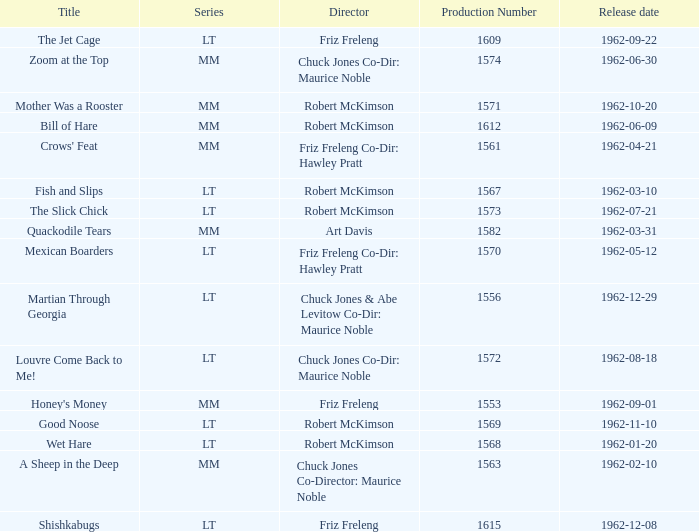What date was Wet Hare, directed by Robert McKimson, released? 1962-01-20. Could you parse the entire table as a dict? {'header': ['Title', 'Series', 'Director', 'Production Number', 'Release date'], 'rows': [['The Jet Cage', 'LT', 'Friz Freleng', '1609', '1962-09-22'], ['Zoom at the Top', 'MM', 'Chuck Jones Co-Dir: Maurice Noble', '1574', '1962-06-30'], ['Mother Was a Rooster', 'MM', 'Robert McKimson', '1571', '1962-10-20'], ['Bill of Hare', 'MM', 'Robert McKimson', '1612', '1962-06-09'], ["Crows' Feat", 'MM', 'Friz Freleng Co-Dir: Hawley Pratt', '1561', '1962-04-21'], ['Fish and Slips', 'LT', 'Robert McKimson', '1567', '1962-03-10'], ['The Slick Chick', 'LT', 'Robert McKimson', '1573', '1962-07-21'], ['Quackodile Tears', 'MM', 'Art Davis', '1582', '1962-03-31'], ['Mexican Boarders', 'LT', 'Friz Freleng Co-Dir: Hawley Pratt', '1570', '1962-05-12'], ['Martian Through Georgia', 'LT', 'Chuck Jones & Abe Levitow Co-Dir: Maurice Noble', '1556', '1962-12-29'], ['Louvre Come Back to Me!', 'LT', 'Chuck Jones Co-Dir: Maurice Noble', '1572', '1962-08-18'], ["Honey's Money", 'MM', 'Friz Freleng', '1553', '1962-09-01'], ['Good Noose', 'LT', 'Robert McKimson', '1569', '1962-11-10'], ['Wet Hare', 'LT', 'Robert McKimson', '1568', '1962-01-20'], ['A Sheep in the Deep', 'MM', 'Chuck Jones Co-Director: Maurice Noble', '1563', '1962-02-10'], ['Shishkabugs', 'LT', 'Friz Freleng', '1615', '1962-12-08']]} 